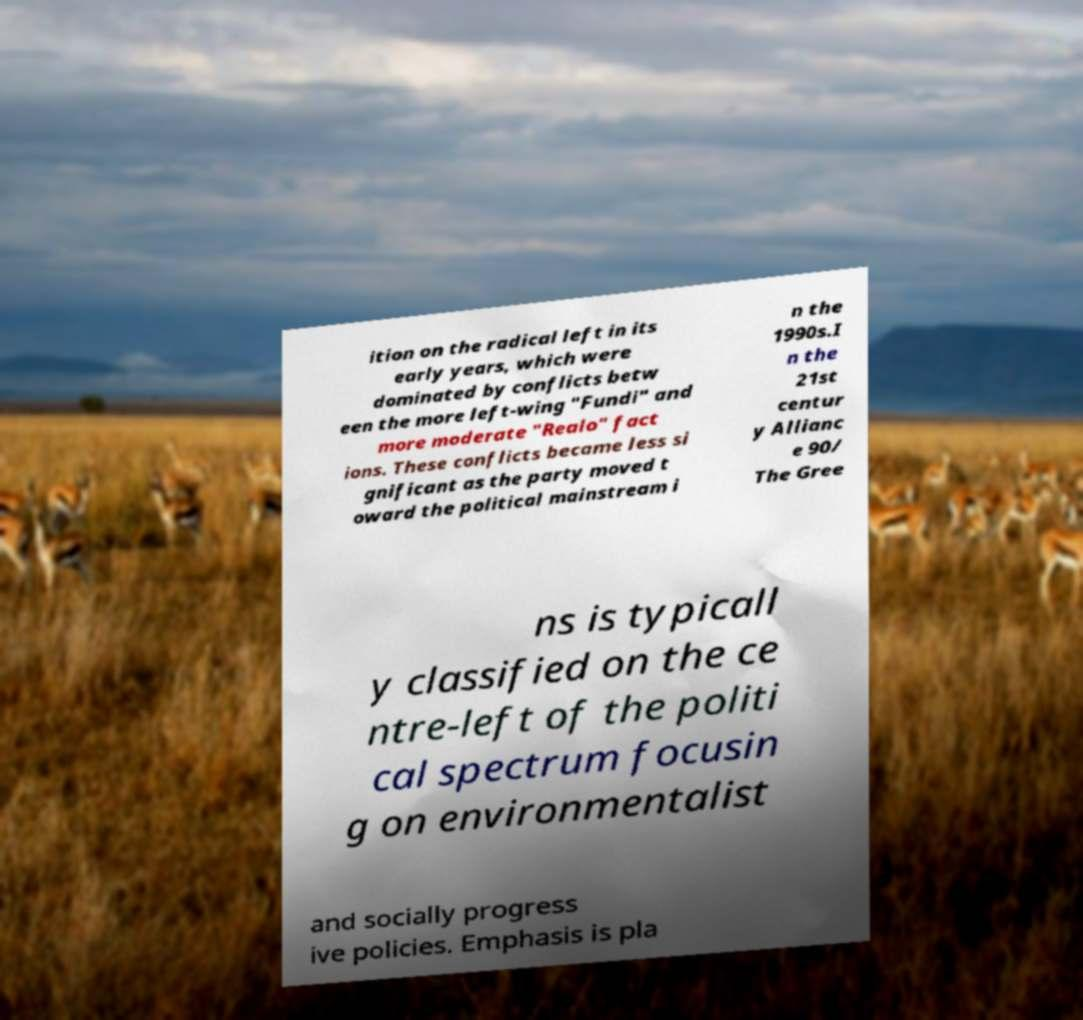Could you extract and type out the text from this image? ition on the radical left in its early years, which were dominated by conflicts betw een the more left-wing "Fundi" and more moderate "Realo" fact ions. These conflicts became less si gnificant as the party moved t oward the political mainstream i n the 1990s.I n the 21st centur y Allianc e 90/ The Gree ns is typicall y classified on the ce ntre-left of the politi cal spectrum focusin g on environmentalist and socially progress ive policies. Emphasis is pla 